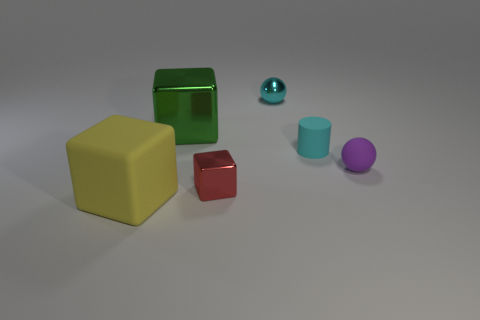Subtract all rubber cubes. How many cubes are left? 2 Subtract all yellow cubes. How many cubes are left? 2 Add 2 large red cylinders. How many objects exist? 8 Subtract 2 spheres. How many spheres are left? 0 Add 3 small purple spheres. How many small purple spheres are left? 4 Add 4 balls. How many balls exist? 6 Subtract 1 yellow blocks. How many objects are left? 5 Subtract all cylinders. How many objects are left? 5 Subtract all red cylinders. Subtract all purple spheres. How many cylinders are left? 1 Subtract all red spheres. How many yellow cylinders are left? 0 